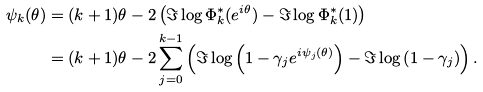Convert formula to latex. <formula><loc_0><loc_0><loc_500><loc_500>\psi _ { k } ( \theta ) & = ( k + 1 ) \theta - 2 \left ( \Im \log \Phi _ { k } ^ { * } ( e ^ { i \theta } ) - \Im \log \Phi _ { k } ^ { * } ( 1 ) \right ) \\ & = ( k + 1 ) \theta - 2 \sum _ { j = 0 } ^ { k - 1 } \left ( \Im \log \left ( 1 - \gamma _ { j } e ^ { i \psi _ { j } ( \theta ) } \right ) - \Im \log \left ( 1 - \gamma _ { j } \right ) \right ) .</formula> 